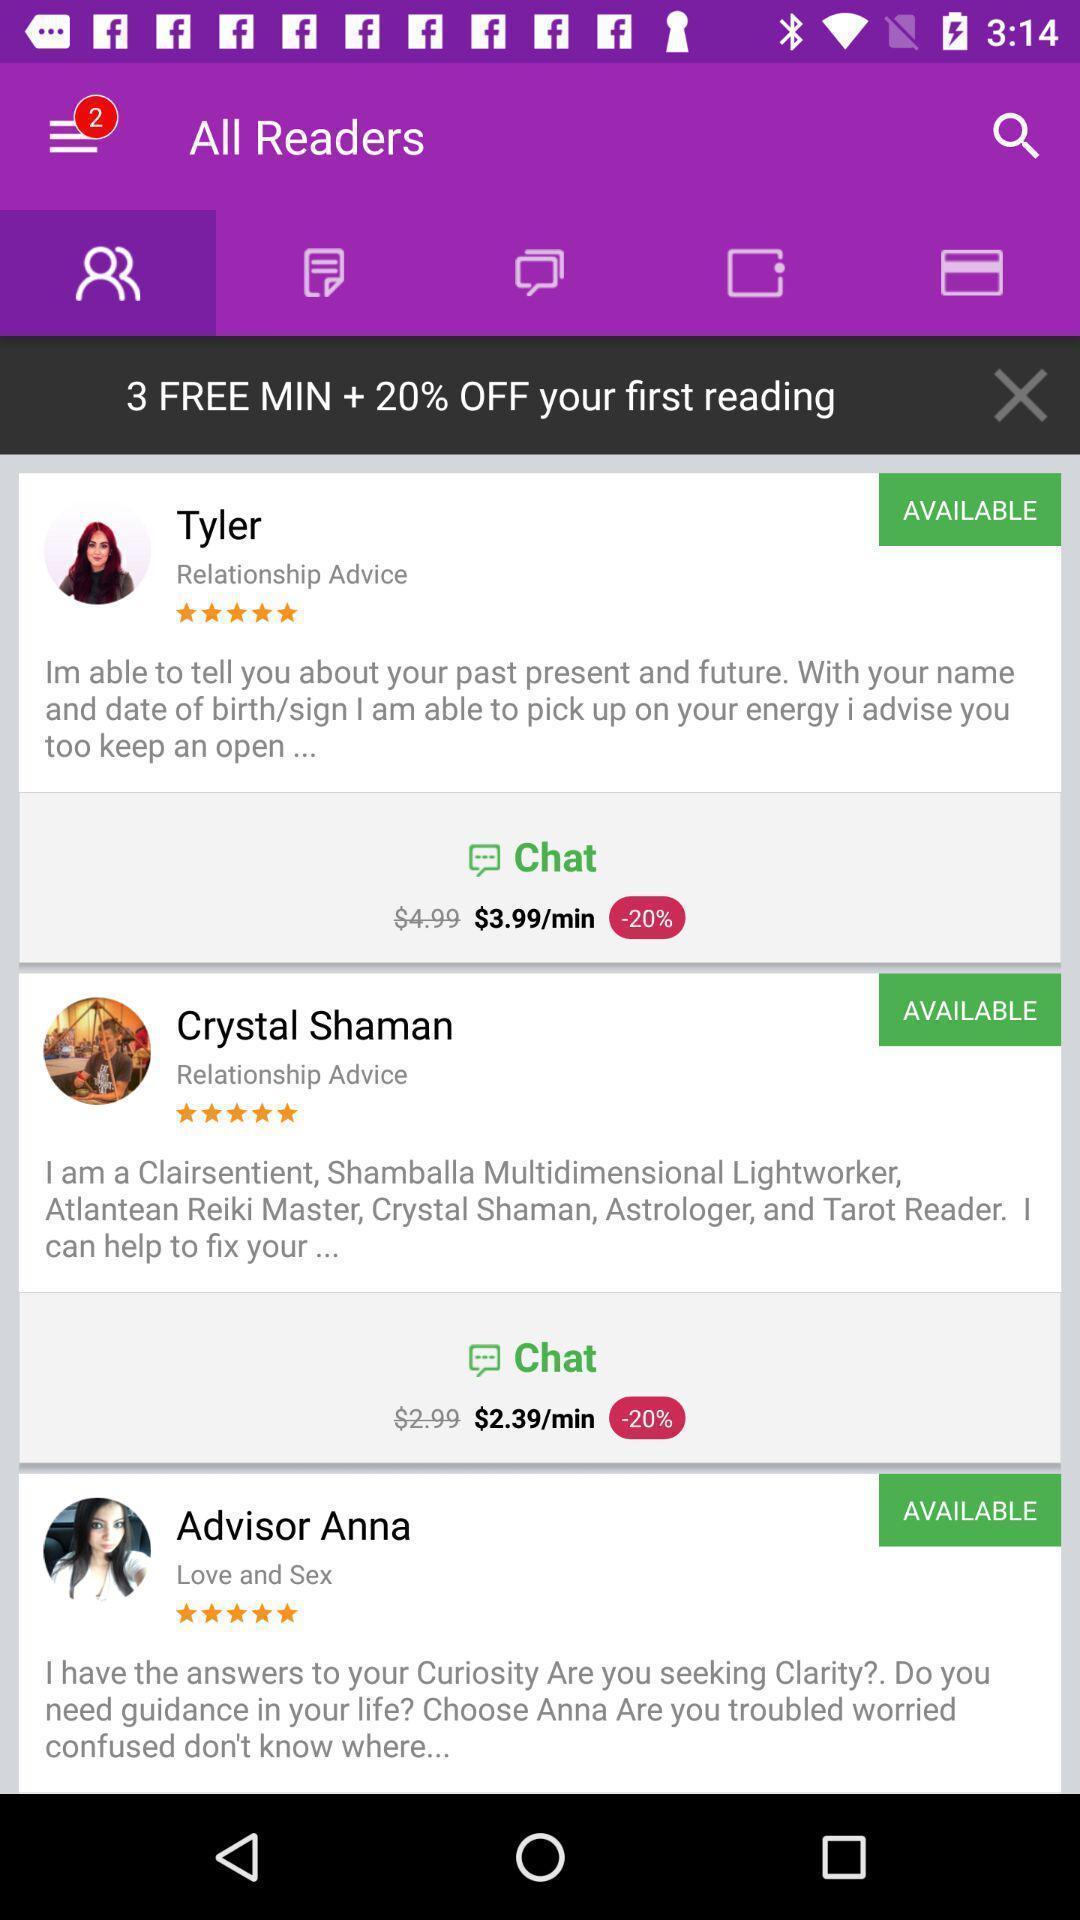What details can you identify in this image? Screen shows chat of experts. 